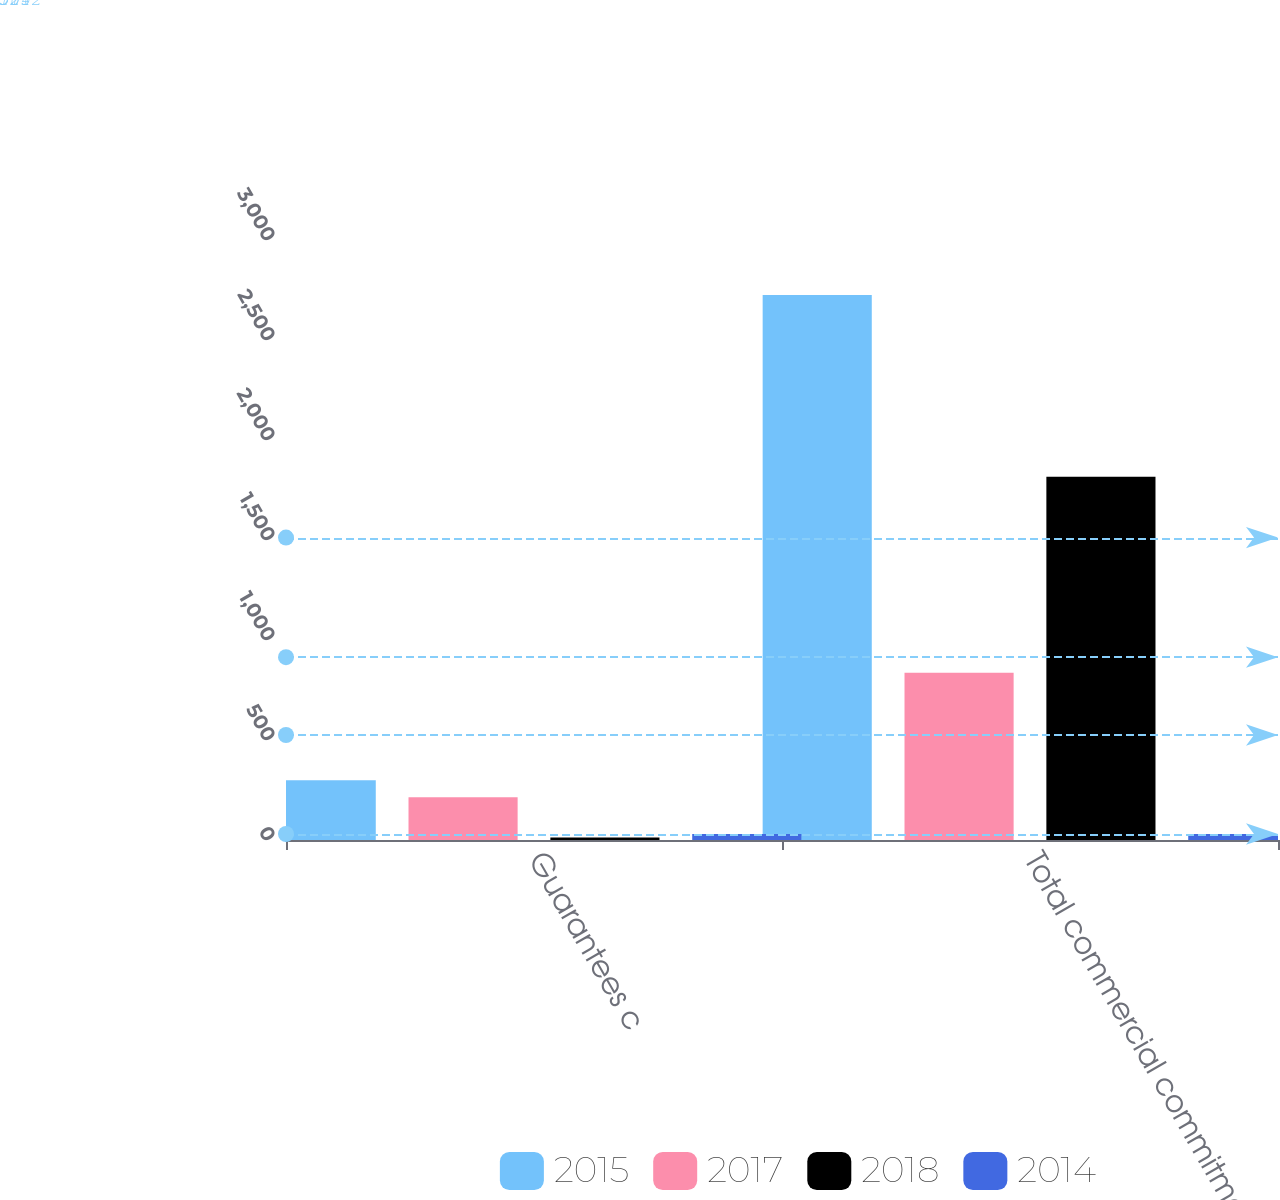Convert chart to OTSL. <chart><loc_0><loc_0><loc_500><loc_500><stacked_bar_chart><ecel><fcel>Guarantees c<fcel>Total commercial commitments<nl><fcel>2015<fcel>299<fcel>2725<nl><fcel>2017<fcel>214<fcel>836<nl><fcel>2018<fcel>12<fcel>1816<nl><fcel>2014<fcel>30<fcel>30<nl></chart> 